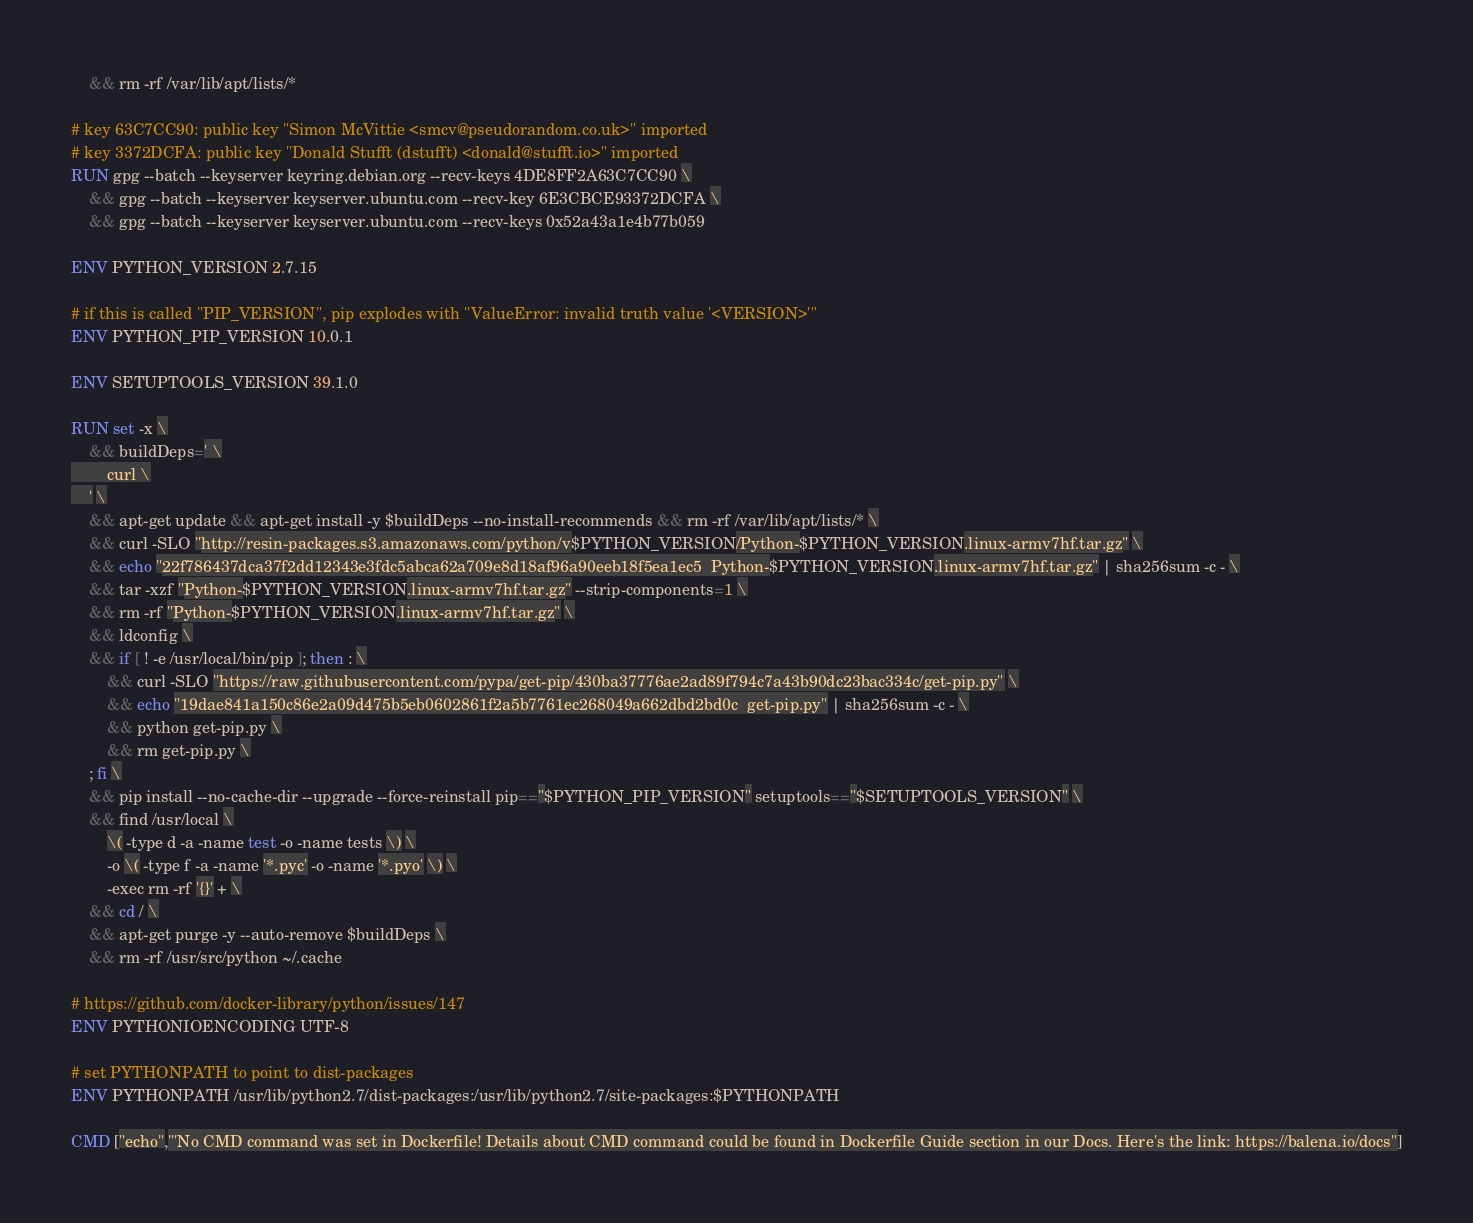Convert code to text. <code><loc_0><loc_0><loc_500><loc_500><_Dockerfile_>	&& rm -rf /var/lib/apt/lists/*

# key 63C7CC90: public key "Simon McVittie <smcv@pseudorandom.co.uk>" imported
# key 3372DCFA: public key "Donald Stufft (dstufft) <donald@stufft.io>" imported
RUN gpg --batch --keyserver keyring.debian.org --recv-keys 4DE8FF2A63C7CC90 \
	&& gpg --batch --keyserver keyserver.ubuntu.com --recv-key 6E3CBCE93372DCFA \
	&& gpg --batch --keyserver keyserver.ubuntu.com --recv-keys 0x52a43a1e4b77b059

ENV PYTHON_VERSION 2.7.15

# if this is called "PIP_VERSION", pip explodes with "ValueError: invalid truth value '<VERSION>'"
ENV PYTHON_PIP_VERSION 10.0.1

ENV SETUPTOOLS_VERSION 39.1.0

RUN set -x \
	&& buildDeps=' \
		curl \
	' \
	&& apt-get update && apt-get install -y $buildDeps --no-install-recommends && rm -rf /var/lib/apt/lists/* \
	&& curl -SLO "http://resin-packages.s3.amazonaws.com/python/v$PYTHON_VERSION/Python-$PYTHON_VERSION.linux-armv7hf.tar.gz" \
	&& echo "22f786437dca37f2dd12343e3fdc5abca62a709e8d18af96a90eeb18f5ea1ec5  Python-$PYTHON_VERSION.linux-armv7hf.tar.gz" | sha256sum -c - \
	&& tar -xzf "Python-$PYTHON_VERSION.linux-armv7hf.tar.gz" --strip-components=1 \
	&& rm -rf "Python-$PYTHON_VERSION.linux-armv7hf.tar.gz" \
	&& ldconfig \
	&& if [ ! -e /usr/local/bin/pip ]; then : \
		&& curl -SLO "https://raw.githubusercontent.com/pypa/get-pip/430ba37776ae2ad89f794c7a43b90dc23bac334c/get-pip.py" \
		&& echo "19dae841a150c86e2a09d475b5eb0602861f2a5b7761ec268049a662dbd2bd0c  get-pip.py" | sha256sum -c - \
		&& python get-pip.py \
		&& rm get-pip.py \
	; fi \
	&& pip install --no-cache-dir --upgrade --force-reinstall pip=="$PYTHON_PIP_VERSION" setuptools=="$SETUPTOOLS_VERSION" \
	&& find /usr/local \
		\( -type d -a -name test -o -name tests \) \
		-o \( -type f -a -name '*.pyc' -o -name '*.pyo' \) \
		-exec rm -rf '{}' + \
	&& cd / \
	&& apt-get purge -y --auto-remove $buildDeps \
	&& rm -rf /usr/src/python ~/.cache

# https://github.com/docker-library/python/issues/147
ENV PYTHONIOENCODING UTF-8

# set PYTHONPATH to point to dist-packages
ENV PYTHONPATH /usr/lib/python2.7/dist-packages:/usr/lib/python2.7/site-packages:$PYTHONPATH

CMD ["echo","'No CMD command was set in Dockerfile! Details about CMD command could be found in Dockerfile Guide section in our Docs. Here's the link: https://balena.io/docs"]</code> 